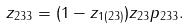<formula> <loc_0><loc_0><loc_500><loc_500>z _ { 2 3 3 } = ( 1 - z _ { 1 ( 2 3 ) } ) z _ { 2 3 } p _ { 2 3 3 } .</formula> 